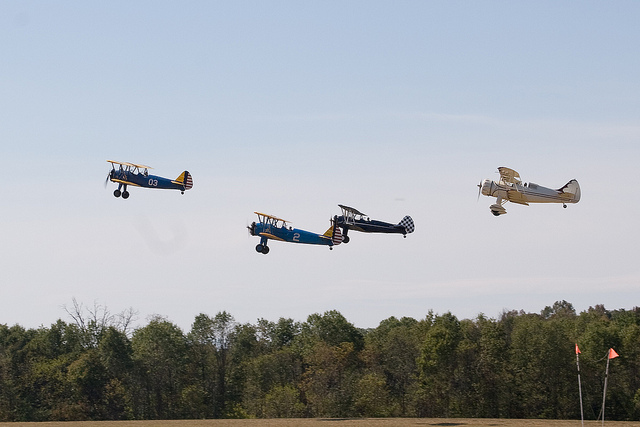Identify and read out the text in this image. D3 e 